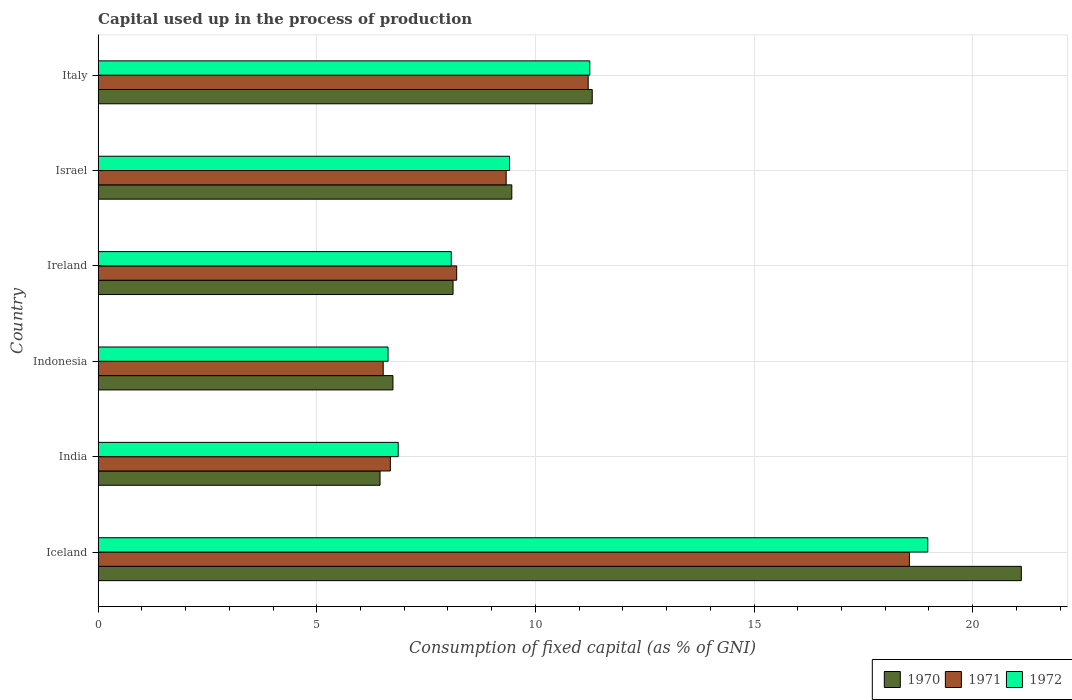How many different coloured bars are there?
Offer a terse response. 3. Are the number of bars per tick equal to the number of legend labels?
Ensure brevity in your answer.  Yes. Are the number of bars on each tick of the Y-axis equal?
Your answer should be very brief. Yes. How many bars are there on the 3rd tick from the bottom?
Provide a succinct answer. 3. In how many cases, is the number of bars for a given country not equal to the number of legend labels?
Your answer should be very brief. 0. What is the capital used up in the process of production in 1970 in Ireland?
Ensure brevity in your answer.  8.12. Across all countries, what is the maximum capital used up in the process of production in 1972?
Your answer should be compact. 18.97. Across all countries, what is the minimum capital used up in the process of production in 1971?
Your response must be concise. 6.52. In which country was the capital used up in the process of production in 1971 minimum?
Your answer should be very brief. Indonesia. What is the total capital used up in the process of production in 1970 in the graph?
Make the answer very short. 63.18. What is the difference between the capital used up in the process of production in 1972 in India and that in Ireland?
Give a very brief answer. -1.21. What is the difference between the capital used up in the process of production in 1970 in Israel and the capital used up in the process of production in 1972 in India?
Your answer should be compact. 2.6. What is the average capital used up in the process of production in 1970 per country?
Ensure brevity in your answer.  10.53. What is the difference between the capital used up in the process of production in 1972 and capital used up in the process of production in 1970 in India?
Your answer should be compact. 0.42. What is the ratio of the capital used up in the process of production in 1972 in Iceland to that in India?
Offer a very short reply. 2.76. Is the capital used up in the process of production in 1971 in India less than that in Indonesia?
Provide a succinct answer. No. Is the difference between the capital used up in the process of production in 1972 in Indonesia and Israel greater than the difference between the capital used up in the process of production in 1970 in Indonesia and Israel?
Your answer should be compact. No. What is the difference between the highest and the second highest capital used up in the process of production in 1972?
Your response must be concise. 7.73. What is the difference between the highest and the lowest capital used up in the process of production in 1972?
Offer a very short reply. 12.34. In how many countries, is the capital used up in the process of production in 1970 greater than the average capital used up in the process of production in 1970 taken over all countries?
Offer a very short reply. 2. Is the sum of the capital used up in the process of production in 1970 in Iceland and Indonesia greater than the maximum capital used up in the process of production in 1972 across all countries?
Your answer should be very brief. Yes. What does the 2nd bar from the top in Ireland represents?
Provide a short and direct response. 1971. What does the 3rd bar from the bottom in India represents?
Make the answer very short. 1972. Is it the case that in every country, the sum of the capital used up in the process of production in 1971 and capital used up in the process of production in 1972 is greater than the capital used up in the process of production in 1970?
Provide a succinct answer. Yes. What is the difference between two consecutive major ticks on the X-axis?
Offer a very short reply. 5. Does the graph contain any zero values?
Offer a very short reply. No. Where does the legend appear in the graph?
Provide a short and direct response. Bottom right. How many legend labels are there?
Make the answer very short. 3. How are the legend labels stacked?
Your answer should be compact. Horizontal. What is the title of the graph?
Provide a short and direct response. Capital used up in the process of production. What is the label or title of the X-axis?
Your answer should be compact. Consumption of fixed capital (as % of GNI). What is the label or title of the Y-axis?
Make the answer very short. Country. What is the Consumption of fixed capital (as % of GNI) of 1970 in Iceland?
Your answer should be compact. 21.11. What is the Consumption of fixed capital (as % of GNI) of 1971 in Iceland?
Your answer should be very brief. 18.55. What is the Consumption of fixed capital (as % of GNI) in 1972 in Iceland?
Your answer should be compact. 18.97. What is the Consumption of fixed capital (as % of GNI) of 1970 in India?
Give a very brief answer. 6.45. What is the Consumption of fixed capital (as % of GNI) in 1971 in India?
Your answer should be very brief. 6.68. What is the Consumption of fixed capital (as % of GNI) in 1972 in India?
Your answer should be very brief. 6.86. What is the Consumption of fixed capital (as % of GNI) in 1970 in Indonesia?
Make the answer very short. 6.74. What is the Consumption of fixed capital (as % of GNI) in 1971 in Indonesia?
Provide a succinct answer. 6.52. What is the Consumption of fixed capital (as % of GNI) in 1972 in Indonesia?
Provide a succinct answer. 6.63. What is the Consumption of fixed capital (as % of GNI) in 1970 in Ireland?
Your answer should be very brief. 8.12. What is the Consumption of fixed capital (as % of GNI) of 1971 in Ireland?
Ensure brevity in your answer.  8.2. What is the Consumption of fixed capital (as % of GNI) of 1972 in Ireland?
Make the answer very short. 8.08. What is the Consumption of fixed capital (as % of GNI) of 1970 in Israel?
Your response must be concise. 9.46. What is the Consumption of fixed capital (as % of GNI) of 1971 in Israel?
Make the answer very short. 9.33. What is the Consumption of fixed capital (as % of GNI) in 1972 in Israel?
Your answer should be compact. 9.41. What is the Consumption of fixed capital (as % of GNI) of 1970 in Italy?
Offer a very short reply. 11.3. What is the Consumption of fixed capital (as % of GNI) in 1971 in Italy?
Give a very brief answer. 11.21. What is the Consumption of fixed capital (as % of GNI) of 1972 in Italy?
Keep it short and to the point. 11.24. Across all countries, what is the maximum Consumption of fixed capital (as % of GNI) in 1970?
Offer a very short reply. 21.11. Across all countries, what is the maximum Consumption of fixed capital (as % of GNI) in 1971?
Give a very brief answer. 18.55. Across all countries, what is the maximum Consumption of fixed capital (as % of GNI) in 1972?
Offer a very short reply. 18.97. Across all countries, what is the minimum Consumption of fixed capital (as % of GNI) of 1970?
Make the answer very short. 6.45. Across all countries, what is the minimum Consumption of fixed capital (as % of GNI) of 1971?
Give a very brief answer. 6.52. Across all countries, what is the minimum Consumption of fixed capital (as % of GNI) in 1972?
Provide a short and direct response. 6.63. What is the total Consumption of fixed capital (as % of GNI) of 1970 in the graph?
Your answer should be very brief. 63.18. What is the total Consumption of fixed capital (as % of GNI) of 1971 in the graph?
Your answer should be very brief. 60.49. What is the total Consumption of fixed capital (as % of GNI) of 1972 in the graph?
Offer a terse response. 61.19. What is the difference between the Consumption of fixed capital (as % of GNI) of 1970 in Iceland and that in India?
Keep it short and to the point. 14.67. What is the difference between the Consumption of fixed capital (as % of GNI) in 1971 in Iceland and that in India?
Ensure brevity in your answer.  11.87. What is the difference between the Consumption of fixed capital (as % of GNI) in 1972 in Iceland and that in India?
Offer a very short reply. 12.11. What is the difference between the Consumption of fixed capital (as % of GNI) of 1970 in Iceland and that in Indonesia?
Your response must be concise. 14.37. What is the difference between the Consumption of fixed capital (as % of GNI) of 1971 in Iceland and that in Indonesia?
Ensure brevity in your answer.  12.03. What is the difference between the Consumption of fixed capital (as % of GNI) of 1972 in Iceland and that in Indonesia?
Your answer should be very brief. 12.34. What is the difference between the Consumption of fixed capital (as % of GNI) in 1970 in Iceland and that in Ireland?
Make the answer very short. 13. What is the difference between the Consumption of fixed capital (as % of GNI) in 1971 in Iceland and that in Ireland?
Offer a very short reply. 10.35. What is the difference between the Consumption of fixed capital (as % of GNI) of 1972 in Iceland and that in Ireland?
Provide a succinct answer. 10.9. What is the difference between the Consumption of fixed capital (as % of GNI) of 1970 in Iceland and that in Israel?
Make the answer very short. 11.65. What is the difference between the Consumption of fixed capital (as % of GNI) in 1971 in Iceland and that in Israel?
Give a very brief answer. 9.22. What is the difference between the Consumption of fixed capital (as % of GNI) of 1972 in Iceland and that in Israel?
Offer a terse response. 9.57. What is the difference between the Consumption of fixed capital (as % of GNI) in 1970 in Iceland and that in Italy?
Offer a terse response. 9.81. What is the difference between the Consumption of fixed capital (as % of GNI) of 1971 in Iceland and that in Italy?
Keep it short and to the point. 7.35. What is the difference between the Consumption of fixed capital (as % of GNI) of 1972 in Iceland and that in Italy?
Your answer should be compact. 7.73. What is the difference between the Consumption of fixed capital (as % of GNI) in 1970 in India and that in Indonesia?
Give a very brief answer. -0.3. What is the difference between the Consumption of fixed capital (as % of GNI) of 1971 in India and that in Indonesia?
Ensure brevity in your answer.  0.16. What is the difference between the Consumption of fixed capital (as % of GNI) of 1972 in India and that in Indonesia?
Your answer should be compact. 0.23. What is the difference between the Consumption of fixed capital (as % of GNI) in 1970 in India and that in Ireland?
Your answer should be very brief. -1.67. What is the difference between the Consumption of fixed capital (as % of GNI) in 1971 in India and that in Ireland?
Give a very brief answer. -1.52. What is the difference between the Consumption of fixed capital (as % of GNI) of 1972 in India and that in Ireland?
Ensure brevity in your answer.  -1.21. What is the difference between the Consumption of fixed capital (as % of GNI) of 1970 in India and that in Israel?
Offer a terse response. -3.01. What is the difference between the Consumption of fixed capital (as % of GNI) of 1971 in India and that in Israel?
Your response must be concise. -2.65. What is the difference between the Consumption of fixed capital (as % of GNI) of 1972 in India and that in Israel?
Give a very brief answer. -2.54. What is the difference between the Consumption of fixed capital (as % of GNI) of 1970 in India and that in Italy?
Give a very brief answer. -4.85. What is the difference between the Consumption of fixed capital (as % of GNI) of 1971 in India and that in Italy?
Provide a succinct answer. -4.52. What is the difference between the Consumption of fixed capital (as % of GNI) of 1972 in India and that in Italy?
Offer a terse response. -4.38. What is the difference between the Consumption of fixed capital (as % of GNI) in 1970 in Indonesia and that in Ireland?
Offer a terse response. -1.37. What is the difference between the Consumption of fixed capital (as % of GNI) in 1971 in Indonesia and that in Ireland?
Provide a succinct answer. -1.68. What is the difference between the Consumption of fixed capital (as % of GNI) in 1972 in Indonesia and that in Ireland?
Make the answer very short. -1.45. What is the difference between the Consumption of fixed capital (as % of GNI) in 1970 in Indonesia and that in Israel?
Your response must be concise. -2.72. What is the difference between the Consumption of fixed capital (as % of GNI) of 1971 in Indonesia and that in Israel?
Your response must be concise. -2.81. What is the difference between the Consumption of fixed capital (as % of GNI) in 1972 in Indonesia and that in Israel?
Offer a very short reply. -2.78. What is the difference between the Consumption of fixed capital (as % of GNI) in 1970 in Indonesia and that in Italy?
Offer a terse response. -4.56. What is the difference between the Consumption of fixed capital (as % of GNI) of 1971 in Indonesia and that in Italy?
Your answer should be compact. -4.69. What is the difference between the Consumption of fixed capital (as % of GNI) in 1972 in Indonesia and that in Italy?
Provide a short and direct response. -4.61. What is the difference between the Consumption of fixed capital (as % of GNI) of 1970 in Ireland and that in Israel?
Ensure brevity in your answer.  -1.34. What is the difference between the Consumption of fixed capital (as % of GNI) of 1971 in Ireland and that in Israel?
Provide a short and direct response. -1.13. What is the difference between the Consumption of fixed capital (as % of GNI) in 1972 in Ireland and that in Israel?
Give a very brief answer. -1.33. What is the difference between the Consumption of fixed capital (as % of GNI) of 1970 in Ireland and that in Italy?
Provide a succinct answer. -3.18. What is the difference between the Consumption of fixed capital (as % of GNI) in 1971 in Ireland and that in Italy?
Ensure brevity in your answer.  -3.01. What is the difference between the Consumption of fixed capital (as % of GNI) in 1972 in Ireland and that in Italy?
Provide a short and direct response. -3.17. What is the difference between the Consumption of fixed capital (as % of GNI) in 1970 in Israel and that in Italy?
Provide a short and direct response. -1.84. What is the difference between the Consumption of fixed capital (as % of GNI) in 1971 in Israel and that in Italy?
Your answer should be compact. -1.88. What is the difference between the Consumption of fixed capital (as % of GNI) of 1972 in Israel and that in Italy?
Give a very brief answer. -1.84. What is the difference between the Consumption of fixed capital (as % of GNI) in 1970 in Iceland and the Consumption of fixed capital (as % of GNI) in 1971 in India?
Your answer should be very brief. 14.43. What is the difference between the Consumption of fixed capital (as % of GNI) of 1970 in Iceland and the Consumption of fixed capital (as % of GNI) of 1972 in India?
Keep it short and to the point. 14.25. What is the difference between the Consumption of fixed capital (as % of GNI) of 1971 in Iceland and the Consumption of fixed capital (as % of GNI) of 1972 in India?
Your answer should be very brief. 11.69. What is the difference between the Consumption of fixed capital (as % of GNI) in 1970 in Iceland and the Consumption of fixed capital (as % of GNI) in 1971 in Indonesia?
Provide a short and direct response. 14.59. What is the difference between the Consumption of fixed capital (as % of GNI) of 1970 in Iceland and the Consumption of fixed capital (as % of GNI) of 1972 in Indonesia?
Keep it short and to the point. 14.48. What is the difference between the Consumption of fixed capital (as % of GNI) in 1971 in Iceland and the Consumption of fixed capital (as % of GNI) in 1972 in Indonesia?
Ensure brevity in your answer.  11.92. What is the difference between the Consumption of fixed capital (as % of GNI) in 1970 in Iceland and the Consumption of fixed capital (as % of GNI) in 1971 in Ireland?
Provide a short and direct response. 12.91. What is the difference between the Consumption of fixed capital (as % of GNI) in 1970 in Iceland and the Consumption of fixed capital (as % of GNI) in 1972 in Ireland?
Give a very brief answer. 13.04. What is the difference between the Consumption of fixed capital (as % of GNI) in 1971 in Iceland and the Consumption of fixed capital (as % of GNI) in 1972 in Ireland?
Offer a very short reply. 10.48. What is the difference between the Consumption of fixed capital (as % of GNI) of 1970 in Iceland and the Consumption of fixed capital (as % of GNI) of 1971 in Israel?
Offer a terse response. 11.78. What is the difference between the Consumption of fixed capital (as % of GNI) in 1970 in Iceland and the Consumption of fixed capital (as % of GNI) in 1972 in Israel?
Ensure brevity in your answer.  11.71. What is the difference between the Consumption of fixed capital (as % of GNI) of 1971 in Iceland and the Consumption of fixed capital (as % of GNI) of 1972 in Israel?
Give a very brief answer. 9.15. What is the difference between the Consumption of fixed capital (as % of GNI) of 1970 in Iceland and the Consumption of fixed capital (as % of GNI) of 1971 in Italy?
Make the answer very short. 9.91. What is the difference between the Consumption of fixed capital (as % of GNI) of 1970 in Iceland and the Consumption of fixed capital (as % of GNI) of 1972 in Italy?
Provide a succinct answer. 9.87. What is the difference between the Consumption of fixed capital (as % of GNI) of 1971 in Iceland and the Consumption of fixed capital (as % of GNI) of 1972 in Italy?
Keep it short and to the point. 7.31. What is the difference between the Consumption of fixed capital (as % of GNI) of 1970 in India and the Consumption of fixed capital (as % of GNI) of 1971 in Indonesia?
Offer a terse response. -0.07. What is the difference between the Consumption of fixed capital (as % of GNI) in 1970 in India and the Consumption of fixed capital (as % of GNI) in 1972 in Indonesia?
Keep it short and to the point. -0.18. What is the difference between the Consumption of fixed capital (as % of GNI) in 1971 in India and the Consumption of fixed capital (as % of GNI) in 1972 in Indonesia?
Offer a terse response. 0.05. What is the difference between the Consumption of fixed capital (as % of GNI) in 1970 in India and the Consumption of fixed capital (as % of GNI) in 1971 in Ireland?
Ensure brevity in your answer.  -1.75. What is the difference between the Consumption of fixed capital (as % of GNI) of 1970 in India and the Consumption of fixed capital (as % of GNI) of 1972 in Ireland?
Offer a terse response. -1.63. What is the difference between the Consumption of fixed capital (as % of GNI) in 1971 in India and the Consumption of fixed capital (as % of GNI) in 1972 in Ireland?
Offer a terse response. -1.39. What is the difference between the Consumption of fixed capital (as % of GNI) in 1970 in India and the Consumption of fixed capital (as % of GNI) in 1971 in Israel?
Your response must be concise. -2.88. What is the difference between the Consumption of fixed capital (as % of GNI) in 1970 in India and the Consumption of fixed capital (as % of GNI) in 1972 in Israel?
Your answer should be very brief. -2.96. What is the difference between the Consumption of fixed capital (as % of GNI) of 1971 in India and the Consumption of fixed capital (as % of GNI) of 1972 in Israel?
Keep it short and to the point. -2.72. What is the difference between the Consumption of fixed capital (as % of GNI) in 1970 in India and the Consumption of fixed capital (as % of GNI) in 1971 in Italy?
Ensure brevity in your answer.  -4.76. What is the difference between the Consumption of fixed capital (as % of GNI) in 1970 in India and the Consumption of fixed capital (as % of GNI) in 1972 in Italy?
Offer a terse response. -4.8. What is the difference between the Consumption of fixed capital (as % of GNI) of 1971 in India and the Consumption of fixed capital (as % of GNI) of 1972 in Italy?
Your answer should be very brief. -4.56. What is the difference between the Consumption of fixed capital (as % of GNI) in 1970 in Indonesia and the Consumption of fixed capital (as % of GNI) in 1971 in Ireland?
Give a very brief answer. -1.46. What is the difference between the Consumption of fixed capital (as % of GNI) of 1970 in Indonesia and the Consumption of fixed capital (as % of GNI) of 1972 in Ireland?
Ensure brevity in your answer.  -1.33. What is the difference between the Consumption of fixed capital (as % of GNI) of 1971 in Indonesia and the Consumption of fixed capital (as % of GNI) of 1972 in Ireland?
Your answer should be very brief. -1.56. What is the difference between the Consumption of fixed capital (as % of GNI) in 1970 in Indonesia and the Consumption of fixed capital (as % of GNI) in 1971 in Israel?
Offer a terse response. -2.59. What is the difference between the Consumption of fixed capital (as % of GNI) in 1970 in Indonesia and the Consumption of fixed capital (as % of GNI) in 1972 in Israel?
Your answer should be very brief. -2.66. What is the difference between the Consumption of fixed capital (as % of GNI) of 1971 in Indonesia and the Consumption of fixed capital (as % of GNI) of 1972 in Israel?
Your answer should be very brief. -2.89. What is the difference between the Consumption of fixed capital (as % of GNI) of 1970 in Indonesia and the Consumption of fixed capital (as % of GNI) of 1971 in Italy?
Your response must be concise. -4.46. What is the difference between the Consumption of fixed capital (as % of GNI) in 1970 in Indonesia and the Consumption of fixed capital (as % of GNI) in 1972 in Italy?
Your answer should be compact. -4.5. What is the difference between the Consumption of fixed capital (as % of GNI) in 1971 in Indonesia and the Consumption of fixed capital (as % of GNI) in 1972 in Italy?
Make the answer very short. -4.72. What is the difference between the Consumption of fixed capital (as % of GNI) of 1970 in Ireland and the Consumption of fixed capital (as % of GNI) of 1971 in Israel?
Make the answer very short. -1.22. What is the difference between the Consumption of fixed capital (as % of GNI) in 1970 in Ireland and the Consumption of fixed capital (as % of GNI) in 1972 in Israel?
Your answer should be very brief. -1.29. What is the difference between the Consumption of fixed capital (as % of GNI) in 1971 in Ireland and the Consumption of fixed capital (as % of GNI) in 1972 in Israel?
Offer a very short reply. -1.21. What is the difference between the Consumption of fixed capital (as % of GNI) in 1970 in Ireland and the Consumption of fixed capital (as % of GNI) in 1971 in Italy?
Your response must be concise. -3.09. What is the difference between the Consumption of fixed capital (as % of GNI) of 1970 in Ireland and the Consumption of fixed capital (as % of GNI) of 1972 in Italy?
Offer a terse response. -3.13. What is the difference between the Consumption of fixed capital (as % of GNI) in 1971 in Ireland and the Consumption of fixed capital (as % of GNI) in 1972 in Italy?
Your answer should be very brief. -3.04. What is the difference between the Consumption of fixed capital (as % of GNI) in 1970 in Israel and the Consumption of fixed capital (as % of GNI) in 1971 in Italy?
Your answer should be very brief. -1.75. What is the difference between the Consumption of fixed capital (as % of GNI) in 1970 in Israel and the Consumption of fixed capital (as % of GNI) in 1972 in Italy?
Give a very brief answer. -1.78. What is the difference between the Consumption of fixed capital (as % of GNI) of 1971 in Israel and the Consumption of fixed capital (as % of GNI) of 1972 in Italy?
Your answer should be compact. -1.91. What is the average Consumption of fixed capital (as % of GNI) of 1970 per country?
Provide a succinct answer. 10.53. What is the average Consumption of fixed capital (as % of GNI) of 1971 per country?
Provide a succinct answer. 10.08. What is the average Consumption of fixed capital (as % of GNI) in 1972 per country?
Offer a terse response. 10.2. What is the difference between the Consumption of fixed capital (as % of GNI) of 1970 and Consumption of fixed capital (as % of GNI) of 1971 in Iceland?
Keep it short and to the point. 2.56. What is the difference between the Consumption of fixed capital (as % of GNI) of 1970 and Consumption of fixed capital (as % of GNI) of 1972 in Iceland?
Your response must be concise. 2.14. What is the difference between the Consumption of fixed capital (as % of GNI) in 1971 and Consumption of fixed capital (as % of GNI) in 1972 in Iceland?
Your answer should be compact. -0.42. What is the difference between the Consumption of fixed capital (as % of GNI) in 1970 and Consumption of fixed capital (as % of GNI) in 1971 in India?
Your answer should be compact. -0.24. What is the difference between the Consumption of fixed capital (as % of GNI) in 1970 and Consumption of fixed capital (as % of GNI) in 1972 in India?
Your answer should be compact. -0.42. What is the difference between the Consumption of fixed capital (as % of GNI) of 1971 and Consumption of fixed capital (as % of GNI) of 1972 in India?
Your answer should be very brief. -0.18. What is the difference between the Consumption of fixed capital (as % of GNI) in 1970 and Consumption of fixed capital (as % of GNI) in 1971 in Indonesia?
Provide a short and direct response. 0.22. What is the difference between the Consumption of fixed capital (as % of GNI) of 1970 and Consumption of fixed capital (as % of GNI) of 1972 in Indonesia?
Your answer should be very brief. 0.11. What is the difference between the Consumption of fixed capital (as % of GNI) of 1971 and Consumption of fixed capital (as % of GNI) of 1972 in Indonesia?
Ensure brevity in your answer.  -0.11. What is the difference between the Consumption of fixed capital (as % of GNI) of 1970 and Consumption of fixed capital (as % of GNI) of 1971 in Ireland?
Provide a short and direct response. -0.08. What is the difference between the Consumption of fixed capital (as % of GNI) in 1970 and Consumption of fixed capital (as % of GNI) in 1972 in Ireland?
Make the answer very short. 0.04. What is the difference between the Consumption of fixed capital (as % of GNI) in 1971 and Consumption of fixed capital (as % of GNI) in 1972 in Ireland?
Your response must be concise. 0.12. What is the difference between the Consumption of fixed capital (as % of GNI) in 1970 and Consumption of fixed capital (as % of GNI) in 1971 in Israel?
Provide a short and direct response. 0.13. What is the difference between the Consumption of fixed capital (as % of GNI) of 1970 and Consumption of fixed capital (as % of GNI) of 1972 in Israel?
Your answer should be compact. 0.05. What is the difference between the Consumption of fixed capital (as % of GNI) of 1971 and Consumption of fixed capital (as % of GNI) of 1972 in Israel?
Keep it short and to the point. -0.08. What is the difference between the Consumption of fixed capital (as % of GNI) in 1970 and Consumption of fixed capital (as % of GNI) in 1971 in Italy?
Make the answer very short. 0.09. What is the difference between the Consumption of fixed capital (as % of GNI) of 1970 and Consumption of fixed capital (as % of GNI) of 1972 in Italy?
Your answer should be compact. 0.06. What is the difference between the Consumption of fixed capital (as % of GNI) of 1971 and Consumption of fixed capital (as % of GNI) of 1972 in Italy?
Offer a very short reply. -0.04. What is the ratio of the Consumption of fixed capital (as % of GNI) in 1970 in Iceland to that in India?
Your answer should be very brief. 3.27. What is the ratio of the Consumption of fixed capital (as % of GNI) in 1971 in Iceland to that in India?
Give a very brief answer. 2.78. What is the ratio of the Consumption of fixed capital (as % of GNI) in 1972 in Iceland to that in India?
Your answer should be compact. 2.76. What is the ratio of the Consumption of fixed capital (as % of GNI) of 1970 in Iceland to that in Indonesia?
Offer a very short reply. 3.13. What is the ratio of the Consumption of fixed capital (as % of GNI) of 1971 in Iceland to that in Indonesia?
Offer a terse response. 2.85. What is the ratio of the Consumption of fixed capital (as % of GNI) of 1972 in Iceland to that in Indonesia?
Provide a succinct answer. 2.86. What is the ratio of the Consumption of fixed capital (as % of GNI) of 1970 in Iceland to that in Ireland?
Offer a terse response. 2.6. What is the ratio of the Consumption of fixed capital (as % of GNI) of 1971 in Iceland to that in Ireland?
Offer a very short reply. 2.26. What is the ratio of the Consumption of fixed capital (as % of GNI) in 1972 in Iceland to that in Ireland?
Your response must be concise. 2.35. What is the ratio of the Consumption of fixed capital (as % of GNI) of 1970 in Iceland to that in Israel?
Provide a succinct answer. 2.23. What is the ratio of the Consumption of fixed capital (as % of GNI) of 1971 in Iceland to that in Israel?
Your response must be concise. 1.99. What is the ratio of the Consumption of fixed capital (as % of GNI) in 1972 in Iceland to that in Israel?
Give a very brief answer. 2.02. What is the ratio of the Consumption of fixed capital (as % of GNI) of 1970 in Iceland to that in Italy?
Ensure brevity in your answer.  1.87. What is the ratio of the Consumption of fixed capital (as % of GNI) of 1971 in Iceland to that in Italy?
Offer a terse response. 1.66. What is the ratio of the Consumption of fixed capital (as % of GNI) in 1972 in Iceland to that in Italy?
Provide a succinct answer. 1.69. What is the ratio of the Consumption of fixed capital (as % of GNI) of 1970 in India to that in Indonesia?
Provide a short and direct response. 0.96. What is the ratio of the Consumption of fixed capital (as % of GNI) of 1971 in India to that in Indonesia?
Your response must be concise. 1.03. What is the ratio of the Consumption of fixed capital (as % of GNI) in 1972 in India to that in Indonesia?
Keep it short and to the point. 1.03. What is the ratio of the Consumption of fixed capital (as % of GNI) of 1970 in India to that in Ireland?
Offer a very short reply. 0.79. What is the ratio of the Consumption of fixed capital (as % of GNI) in 1971 in India to that in Ireland?
Give a very brief answer. 0.81. What is the ratio of the Consumption of fixed capital (as % of GNI) in 1972 in India to that in Ireland?
Your response must be concise. 0.85. What is the ratio of the Consumption of fixed capital (as % of GNI) of 1970 in India to that in Israel?
Ensure brevity in your answer.  0.68. What is the ratio of the Consumption of fixed capital (as % of GNI) in 1971 in India to that in Israel?
Give a very brief answer. 0.72. What is the ratio of the Consumption of fixed capital (as % of GNI) of 1972 in India to that in Israel?
Your answer should be very brief. 0.73. What is the ratio of the Consumption of fixed capital (as % of GNI) of 1970 in India to that in Italy?
Give a very brief answer. 0.57. What is the ratio of the Consumption of fixed capital (as % of GNI) of 1971 in India to that in Italy?
Your response must be concise. 0.6. What is the ratio of the Consumption of fixed capital (as % of GNI) of 1972 in India to that in Italy?
Ensure brevity in your answer.  0.61. What is the ratio of the Consumption of fixed capital (as % of GNI) of 1970 in Indonesia to that in Ireland?
Your answer should be very brief. 0.83. What is the ratio of the Consumption of fixed capital (as % of GNI) of 1971 in Indonesia to that in Ireland?
Your answer should be very brief. 0.8. What is the ratio of the Consumption of fixed capital (as % of GNI) of 1972 in Indonesia to that in Ireland?
Your response must be concise. 0.82. What is the ratio of the Consumption of fixed capital (as % of GNI) in 1970 in Indonesia to that in Israel?
Offer a very short reply. 0.71. What is the ratio of the Consumption of fixed capital (as % of GNI) in 1971 in Indonesia to that in Israel?
Your answer should be very brief. 0.7. What is the ratio of the Consumption of fixed capital (as % of GNI) in 1972 in Indonesia to that in Israel?
Your answer should be very brief. 0.7. What is the ratio of the Consumption of fixed capital (as % of GNI) of 1970 in Indonesia to that in Italy?
Your answer should be very brief. 0.6. What is the ratio of the Consumption of fixed capital (as % of GNI) in 1971 in Indonesia to that in Italy?
Your response must be concise. 0.58. What is the ratio of the Consumption of fixed capital (as % of GNI) in 1972 in Indonesia to that in Italy?
Provide a short and direct response. 0.59. What is the ratio of the Consumption of fixed capital (as % of GNI) in 1970 in Ireland to that in Israel?
Your response must be concise. 0.86. What is the ratio of the Consumption of fixed capital (as % of GNI) in 1971 in Ireland to that in Israel?
Provide a succinct answer. 0.88. What is the ratio of the Consumption of fixed capital (as % of GNI) of 1972 in Ireland to that in Israel?
Your answer should be compact. 0.86. What is the ratio of the Consumption of fixed capital (as % of GNI) of 1970 in Ireland to that in Italy?
Offer a terse response. 0.72. What is the ratio of the Consumption of fixed capital (as % of GNI) in 1971 in Ireland to that in Italy?
Your answer should be compact. 0.73. What is the ratio of the Consumption of fixed capital (as % of GNI) in 1972 in Ireland to that in Italy?
Your answer should be compact. 0.72. What is the ratio of the Consumption of fixed capital (as % of GNI) in 1970 in Israel to that in Italy?
Your answer should be compact. 0.84. What is the ratio of the Consumption of fixed capital (as % of GNI) of 1971 in Israel to that in Italy?
Offer a terse response. 0.83. What is the ratio of the Consumption of fixed capital (as % of GNI) of 1972 in Israel to that in Italy?
Offer a terse response. 0.84. What is the difference between the highest and the second highest Consumption of fixed capital (as % of GNI) of 1970?
Make the answer very short. 9.81. What is the difference between the highest and the second highest Consumption of fixed capital (as % of GNI) of 1971?
Offer a very short reply. 7.35. What is the difference between the highest and the second highest Consumption of fixed capital (as % of GNI) in 1972?
Offer a terse response. 7.73. What is the difference between the highest and the lowest Consumption of fixed capital (as % of GNI) in 1970?
Your response must be concise. 14.67. What is the difference between the highest and the lowest Consumption of fixed capital (as % of GNI) of 1971?
Offer a terse response. 12.03. What is the difference between the highest and the lowest Consumption of fixed capital (as % of GNI) of 1972?
Offer a terse response. 12.34. 